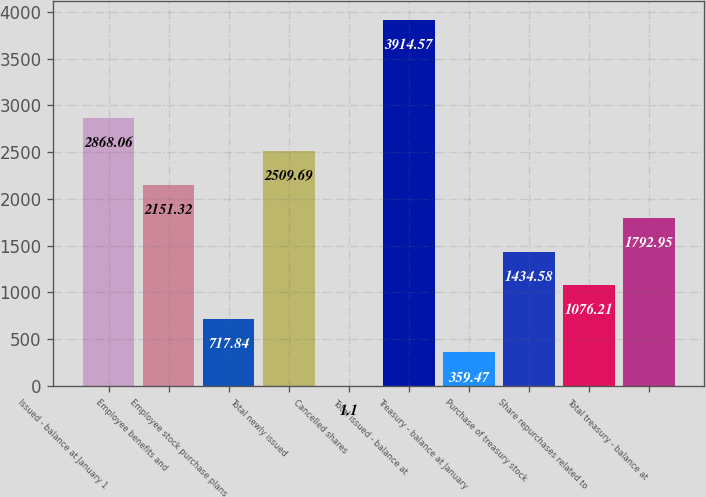Convert chart. <chart><loc_0><loc_0><loc_500><loc_500><bar_chart><fcel>Issued - balance at January 1<fcel>Employee benefits and<fcel>Employee stock purchase plans<fcel>Total newly issued<fcel>Cancelled shares<fcel>Total issued - balance at<fcel>Treasury - balance at January<fcel>Purchase of treasury stock<fcel>Share repurchases related to<fcel>Total treasury - balance at<nl><fcel>2868.06<fcel>2151.32<fcel>717.84<fcel>2509.69<fcel>1.1<fcel>3914.57<fcel>359.47<fcel>1434.58<fcel>1076.21<fcel>1792.95<nl></chart> 